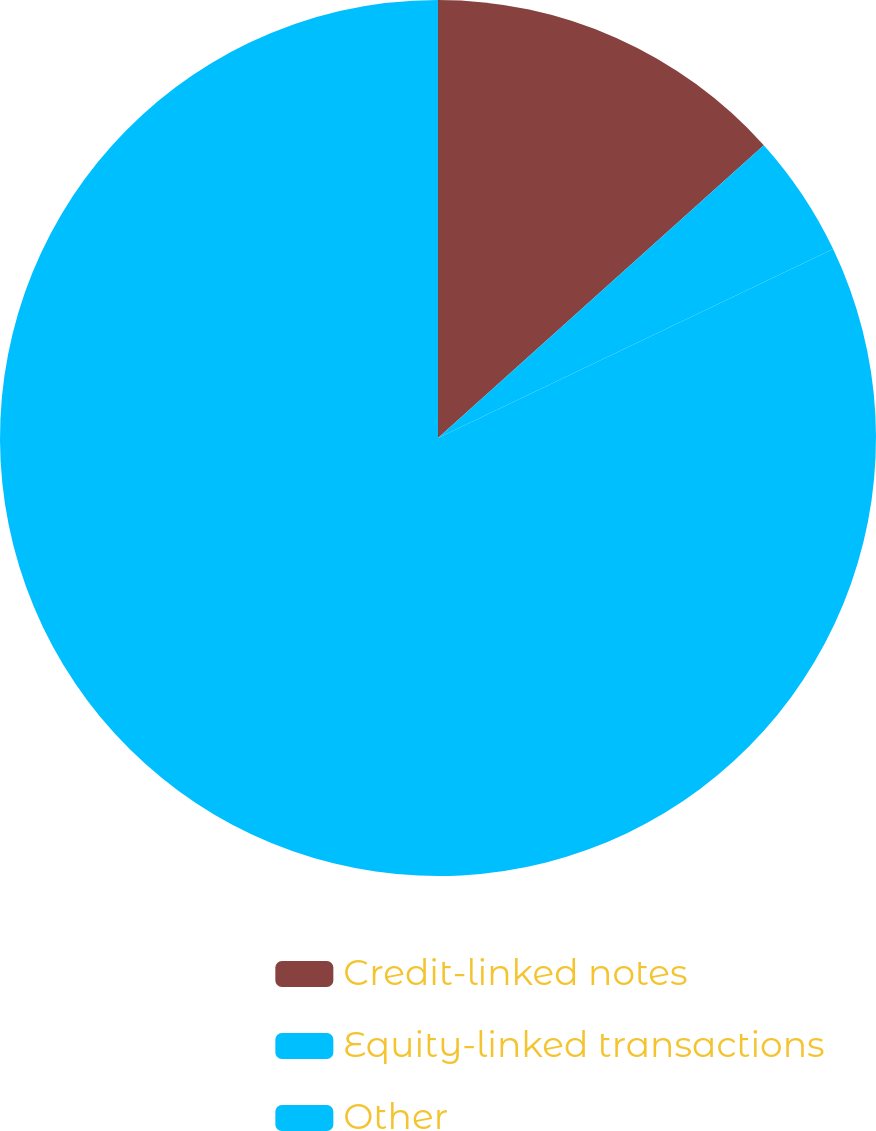<chart> <loc_0><loc_0><loc_500><loc_500><pie_chart><fcel>Credit-linked notes<fcel>Equity-linked transactions<fcel>Other<nl><fcel>13.35%<fcel>4.55%<fcel>82.1%<nl></chart> 